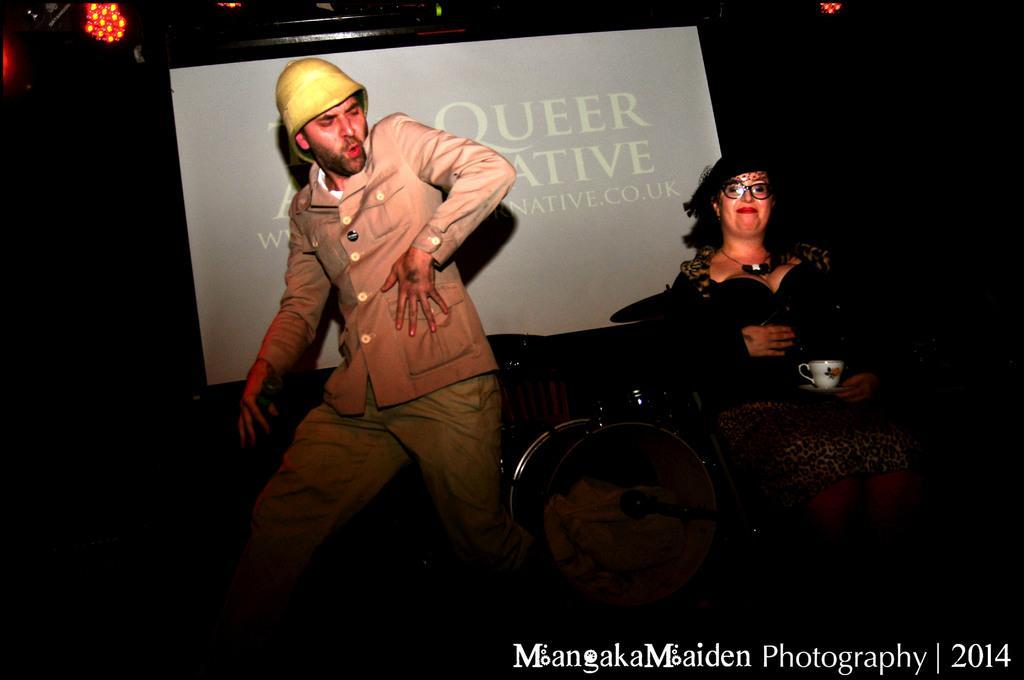In one or two sentences, can you explain what this image depicts? In this image in the front there are persons standing and sitting and there is a woman holding a cup in her hand and smiling. In the background there is a board with some text written on it and there are lights on the top and there is some text written on the image with some numbers. 